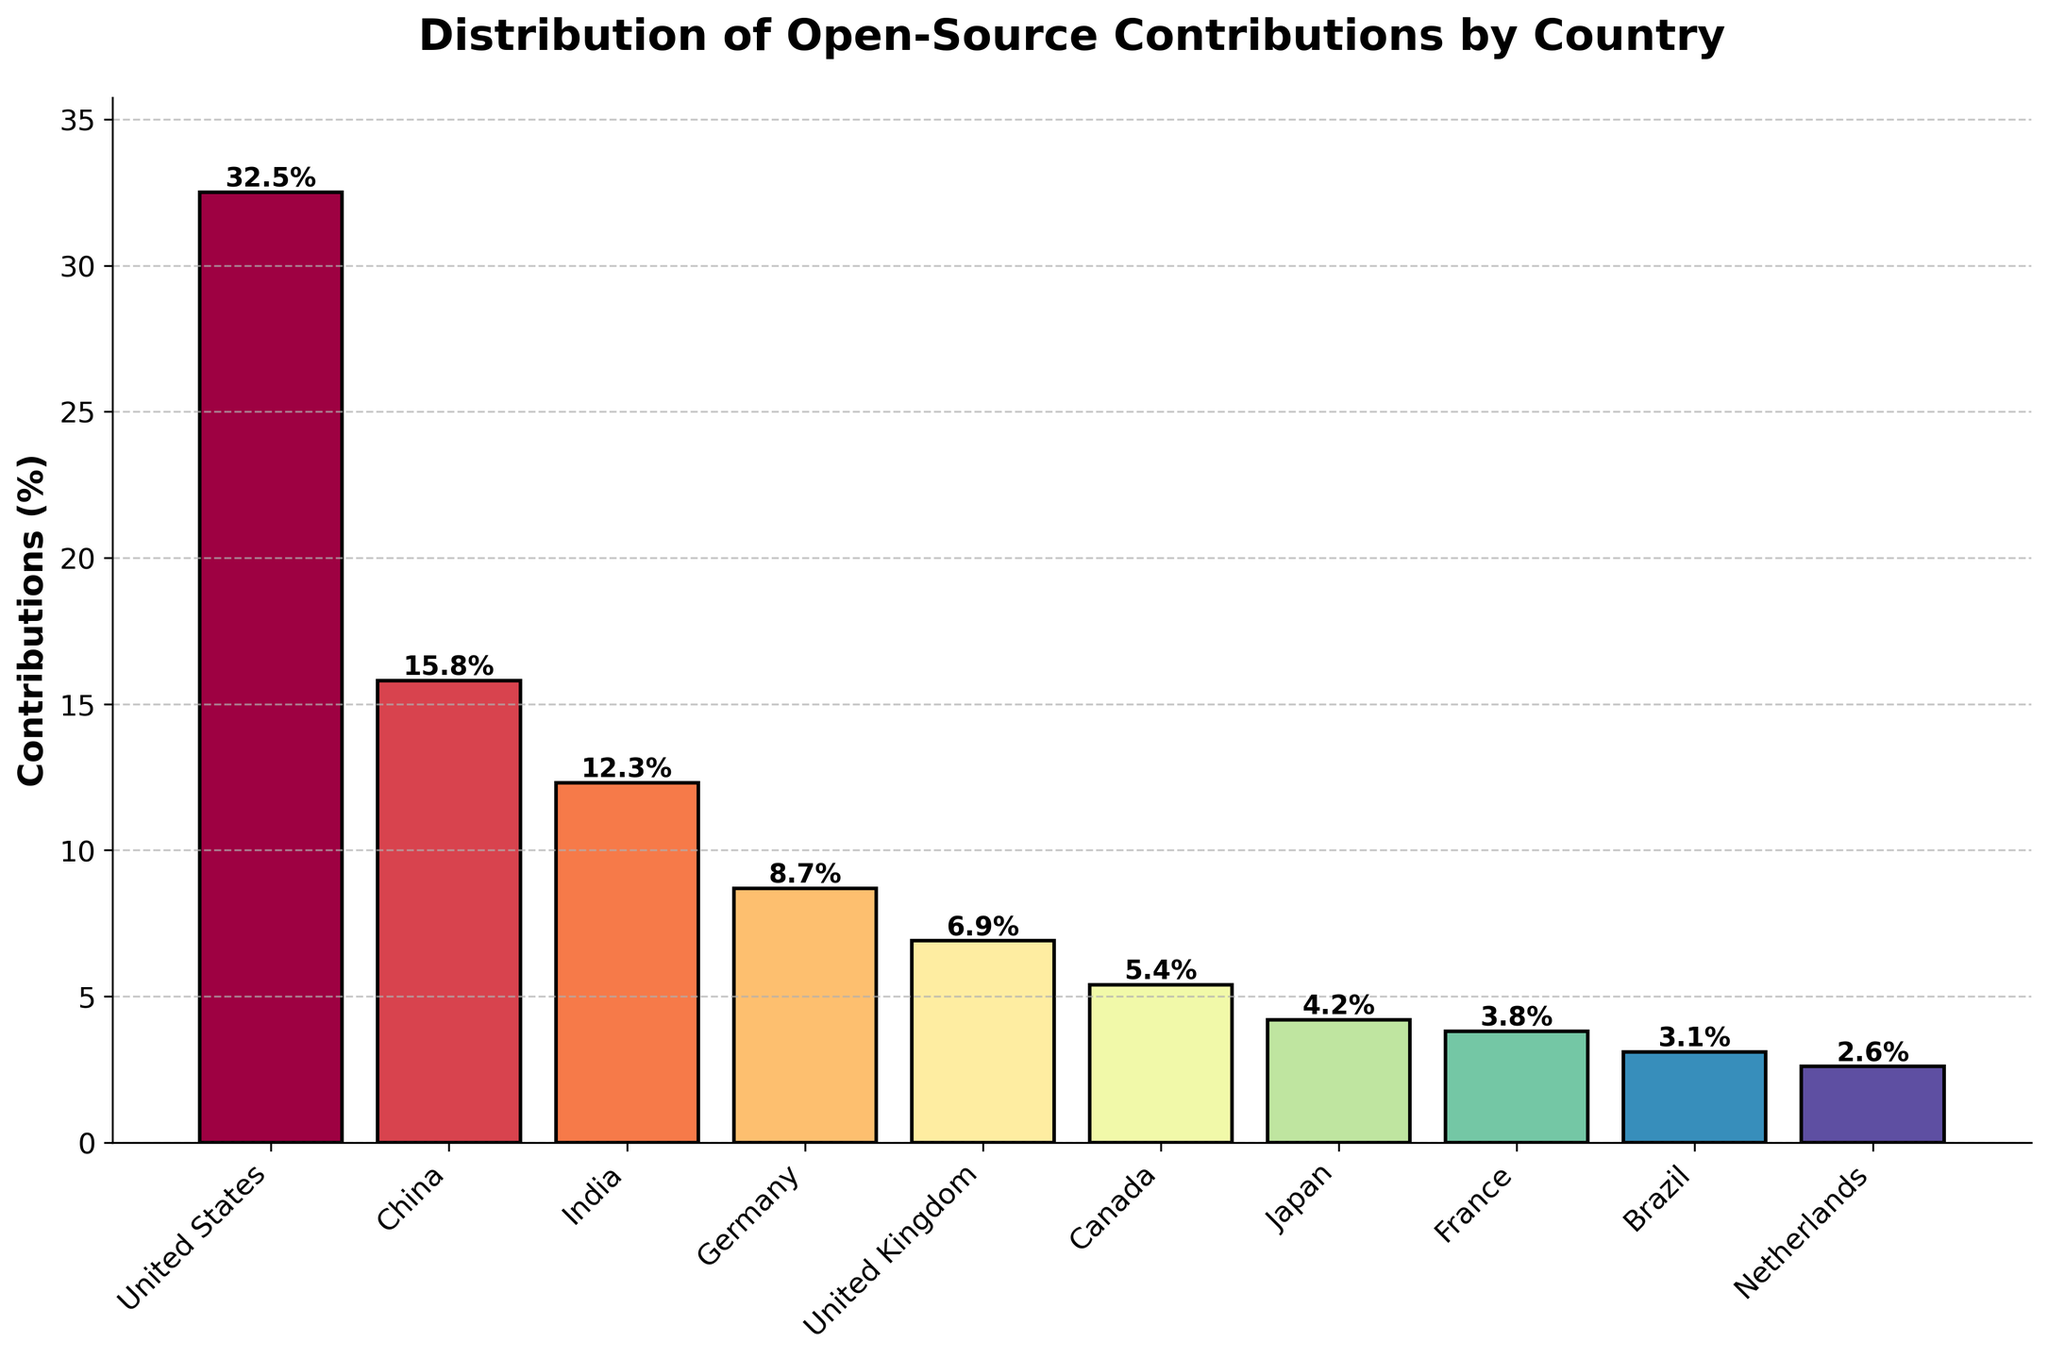Which country has the highest percentage of open-source contributions? The bar chart displays the relative contributions by country, where the highest bar, representing the largest percentage, belongs to the United States.
Answer: United States Among the top 10 countries, which has the lowest percentage of contributions? By looking at the lengths of the bars, the shortest bar corresponds to the Netherlands, indicating it has the lowest percentage contribution among the listed countries.
Answer: Netherlands How much higher is the contribution percentage of the United States compared to France? The contribution of the United States is 32.5%, and France has 3.8%. The difference is calculated as 32.5% - 3.8% = 28.7%.
Answer: 28.7% Which two countries have a collective contribution percentage greater than 20% but less than 30%? Looking for pairs of countries whose contributions sum between 20% and 30%. China (15.8%) and India (12.3%) together contribute 28.1%, which fits within the defined range.
Answer: China and India What is the average contribution percentage of the top 3 contributing countries? The top 3 countries are the United States (32.5%), China (15.8%), and India (12.3%). Their average contribution is (32.5 + 15.8 + 12.3) / 3 = 20.2%.
Answer: 20.2% Is the contribution percentage of Germany closer to that of Canada or the United Kingdom? Germany's contribution is 8.7%, Canada's is 5.4%, and the United Kingdom's is 6.9%. The differences are 8.7 - 5.4 = 3.3%, and 8.7 - 6.9 = 1.8%. Thus, Germany's contribution is closer to the United Kingdom.
Answer: United Kingdom What's the total contribution percentage of the countries with less than 5% individual contributions? Sum the contributions of Japan (4.2%), France (3.8%), Brazil (3.1%), and Netherlands (2.6%): 4.2 + 3.8 + 3.1 + 2.6 = 13.7%.
Answer: 13.7% Rank the countries by contribution percentage in descending order. Referring to the bar chart, the order from highest to lowest contribution is: United States, China, India, Germany, United Kingdom, Canada, Japan, France, Brazil, Netherlands.
Answer: United States, China, India, Germany, United Kingdom, Canada, Japan, France, Brazil, Netherlands Which country has a contribution percentage closely approaching half of China's contributions? China has a 15.8% contribution; half of this is 7.9%. Germany's contribution is 8.7%, which is the closest to this value.
Answer: Germany What is the sum of contributions from European countries on the list? The European countries are Germany (8.7%), United Kingdom (6.9%), France (3.8%), and Netherlands (2.6%). Their total contribution is 8.7 + 6.9 + 3.8 + 2.6 = 22%.
Answer: 22% 